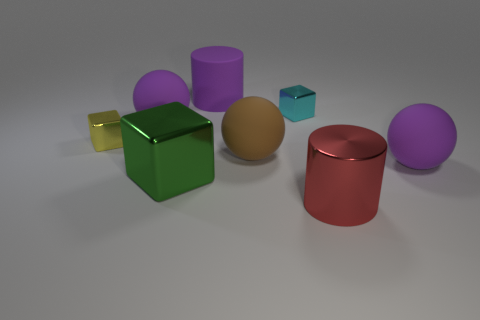Subtract all large purple balls. How many balls are left? 1 Add 2 metallic cubes. How many objects exist? 10 Subtract all green cylinders. How many purple spheres are left? 2 Subtract all yellow cubes. How many cubes are left? 2 Subtract all cubes. How many objects are left? 5 Subtract 2 cubes. How many cubes are left? 1 Subtract 1 red cylinders. How many objects are left? 7 Subtract all yellow cubes. Subtract all brown cylinders. How many cubes are left? 2 Subtract all purple metallic things. Subtract all large red shiny cylinders. How many objects are left? 7 Add 1 red metal objects. How many red metal objects are left? 2 